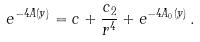<formula> <loc_0><loc_0><loc_500><loc_500>e ^ { - 4 A ( y ) } = c + \frac { c _ { 2 } } { r ^ { 4 } } + e ^ { - 4 A _ { 0 } ( y ) } \, .</formula> 